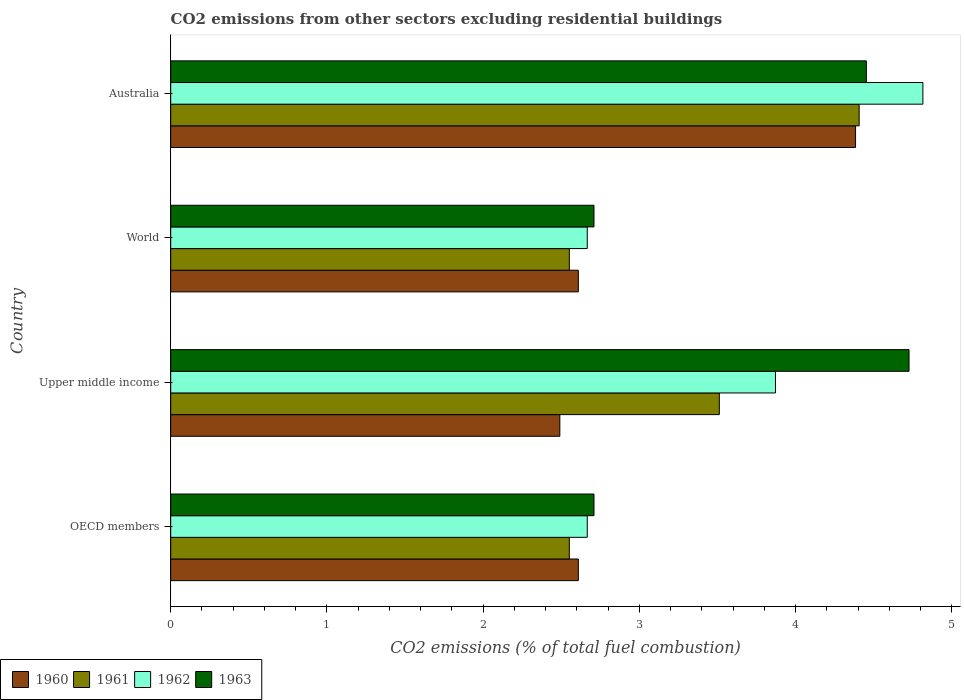How many bars are there on the 1st tick from the top?
Offer a terse response. 4. How many bars are there on the 4th tick from the bottom?
Provide a short and direct response. 4. What is the label of the 4th group of bars from the top?
Offer a terse response. OECD members. What is the total CO2 emitted in 1960 in World?
Provide a succinct answer. 2.61. Across all countries, what is the maximum total CO2 emitted in 1961?
Provide a short and direct response. 4.41. Across all countries, what is the minimum total CO2 emitted in 1961?
Give a very brief answer. 2.55. In which country was the total CO2 emitted in 1960 maximum?
Give a very brief answer. Australia. In which country was the total CO2 emitted in 1961 minimum?
Make the answer very short. OECD members. What is the total total CO2 emitted in 1963 in the graph?
Keep it short and to the point. 14.6. What is the difference between the total CO2 emitted in 1960 in Australia and that in Upper middle income?
Your response must be concise. 1.89. What is the difference between the total CO2 emitted in 1962 in OECD members and the total CO2 emitted in 1963 in Australia?
Offer a very short reply. -1.79. What is the average total CO2 emitted in 1960 per country?
Offer a terse response. 3.02. What is the difference between the total CO2 emitted in 1962 and total CO2 emitted in 1961 in OECD members?
Provide a short and direct response. 0.11. In how many countries, is the total CO2 emitted in 1963 greater than 1.6 ?
Your answer should be compact. 4. What is the ratio of the total CO2 emitted in 1960 in Australia to that in World?
Keep it short and to the point. 1.68. What is the difference between the highest and the second highest total CO2 emitted in 1962?
Your answer should be compact. 0.94. What is the difference between the highest and the lowest total CO2 emitted in 1963?
Your answer should be very brief. 2.02. In how many countries, is the total CO2 emitted in 1962 greater than the average total CO2 emitted in 1962 taken over all countries?
Your response must be concise. 2. What does the 2nd bar from the bottom in World represents?
Ensure brevity in your answer.  1961. Are all the bars in the graph horizontal?
Your answer should be compact. Yes. What is the difference between two consecutive major ticks on the X-axis?
Provide a short and direct response. 1. Does the graph contain grids?
Give a very brief answer. No. What is the title of the graph?
Offer a very short reply. CO2 emissions from other sectors excluding residential buildings. Does "1991" appear as one of the legend labels in the graph?
Your answer should be very brief. No. What is the label or title of the X-axis?
Keep it short and to the point. CO2 emissions (% of total fuel combustion). What is the CO2 emissions (% of total fuel combustion) in 1960 in OECD members?
Make the answer very short. 2.61. What is the CO2 emissions (% of total fuel combustion) of 1961 in OECD members?
Make the answer very short. 2.55. What is the CO2 emissions (% of total fuel combustion) in 1962 in OECD members?
Your answer should be very brief. 2.67. What is the CO2 emissions (% of total fuel combustion) in 1963 in OECD members?
Make the answer very short. 2.71. What is the CO2 emissions (% of total fuel combustion) in 1960 in Upper middle income?
Offer a terse response. 2.49. What is the CO2 emissions (% of total fuel combustion) in 1961 in Upper middle income?
Provide a succinct answer. 3.51. What is the CO2 emissions (% of total fuel combustion) in 1962 in Upper middle income?
Your response must be concise. 3.87. What is the CO2 emissions (% of total fuel combustion) of 1963 in Upper middle income?
Ensure brevity in your answer.  4.73. What is the CO2 emissions (% of total fuel combustion) of 1960 in World?
Your response must be concise. 2.61. What is the CO2 emissions (% of total fuel combustion) in 1961 in World?
Your answer should be very brief. 2.55. What is the CO2 emissions (% of total fuel combustion) in 1962 in World?
Keep it short and to the point. 2.67. What is the CO2 emissions (% of total fuel combustion) in 1963 in World?
Provide a short and direct response. 2.71. What is the CO2 emissions (% of total fuel combustion) of 1960 in Australia?
Provide a succinct answer. 4.38. What is the CO2 emissions (% of total fuel combustion) in 1961 in Australia?
Offer a terse response. 4.41. What is the CO2 emissions (% of total fuel combustion) in 1962 in Australia?
Your response must be concise. 4.82. What is the CO2 emissions (% of total fuel combustion) of 1963 in Australia?
Offer a terse response. 4.45. Across all countries, what is the maximum CO2 emissions (% of total fuel combustion) in 1960?
Ensure brevity in your answer.  4.38. Across all countries, what is the maximum CO2 emissions (% of total fuel combustion) in 1961?
Offer a very short reply. 4.41. Across all countries, what is the maximum CO2 emissions (% of total fuel combustion) of 1962?
Give a very brief answer. 4.82. Across all countries, what is the maximum CO2 emissions (% of total fuel combustion) of 1963?
Provide a succinct answer. 4.73. Across all countries, what is the minimum CO2 emissions (% of total fuel combustion) in 1960?
Your answer should be very brief. 2.49. Across all countries, what is the minimum CO2 emissions (% of total fuel combustion) of 1961?
Offer a terse response. 2.55. Across all countries, what is the minimum CO2 emissions (% of total fuel combustion) in 1962?
Offer a terse response. 2.67. Across all countries, what is the minimum CO2 emissions (% of total fuel combustion) of 1963?
Your answer should be very brief. 2.71. What is the total CO2 emissions (% of total fuel combustion) in 1960 in the graph?
Keep it short and to the point. 12.09. What is the total CO2 emissions (% of total fuel combustion) of 1961 in the graph?
Provide a succinct answer. 13.02. What is the total CO2 emissions (% of total fuel combustion) of 1962 in the graph?
Keep it short and to the point. 14.02. What is the total CO2 emissions (% of total fuel combustion) in 1963 in the graph?
Your answer should be compact. 14.6. What is the difference between the CO2 emissions (% of total fuel combustion) of 1960 in OECD members and that in Upper middle income?
Your answer should be compact. 0.12. What is the difference between the CO2 emissions (% of total fuel combustion) of 1961 in OECD members and that in Upper middle income?
Offer a terse response. -0.96. What is the difference between the CO2 emissions (% of total fuel combustion) in 1962 in OECD members and that in Upper middle income?
Ensure brevity in your answer.  -1.2. What is the difference between the CO2 emissions (% of total fuel combustion) in 1963 in OECD members and that in Upper middle income?
Offer a very short reply. -2.02. What is the difference between the CO2 emissions (% of total fuel combustion) of 1960 in OECD members and that in World?
Provide a short and direct response. 0. What is the difference between the CO2 emissions (% of total fuel combustion) of 1962 in OECD members and that in World?
Offer a terse response. 0. What is the difference between the CO2 emissions (% of total fuel combustion) in 1960 in OECD members and that in Australia?
Keep it short and to the point. -1.77. What is the difference between the CO2 emissions (% of total fuel combustion) in 1961 in OECD members and that in Australia?
Offer a very short reply. -1.86. What is the difference between the CO2 emissions (% of total fuel combustion) in 1962 in OECD members and that in Australia?
Offer a terse response. -2.15. What is the difference between the CO2 emissions (% of total fuel combustion) in 1963 in OECD members and that in Australia?
Provide a short and direct response. -1.74. What is the difference between the CO2 emissions (% of total fuel combustion) in 1960 in Upper middle income and that in World?
Keep it short and to the point. -0.12. What is the difference between the CO2 emissions (% of total fuel combustion) of 1961 in Upper middle income and that in World?
Give a very brief answer. 0.96. What is the difference between the CO2 emissions (% of total fuel combustion) of 1962 in Upper middle income and that in World?
Offer a very short reply. 1.2. What is the difference between the CO2 emissions (% of total fuel combustion) of 1963 in Upper middle income and that in World?
Your answer should be compact. 2.02. What is the difference between the CO2 emissions (% of total fuel combustion) of 1960 in Upper middle income and that in Australia?
Provide a short and direct response. -1.89. What is the difference between the CO2 emissions (% of total fuel combustion) in 1961 in Upper middle income and that in Australia?
Give a very brief answer. -0.9. What is the difference between the CO2 emissions (% of total fuel combustion) in 1962 in Upper middle income and that in Australia?
Your response must be concise. -0.94. What is the difference between the CO2 emissions (% of total fuel combustion) of 1963 in Upper middle income and that in Australia?
Ensure brevity in your answer.  0.27. What is the difference between the CO2 emissions (% of total fuel combustion) in 1960 in World and that in Australia?
Ensure brevity in your answer.  -1.77. What is the difference between the CO2 emissions (% of total fuel combustion) of 1961 in World and that in Australia?
Give a very brief answer. -1.86. What is the difference between the CO2 emissions (% of total fuel combustion) in 1962 in World and that in Australia?
Provide a short and direct response. -2.15. What is the difference between the CO2 emissions (% of total fuel combustion) of 1963 in World and that in Australia?
Offer a very short reply. -1.74. What is the difference between the CO2 emissions (% of total fuel combustion) in 1960 in OECD members and the CO2 emissions (% of total fuel combustion) in 1961 in Upper middle income?
Provide a succinct answer. -0.9. What is the difference between the CO2 emissions (% of total fuel combustion) of 1960 in OECD members and the CO2 emissions (% of total fuel combustion) of 1962 in Upper middle income?
Offer a terse response. -1.26. What is the difference between the CO2 emissions (% of total fuel combustion) in 1960 in OECD members and the CO2 emissions (% of total fuel combustion) in 1963 in Upper middle income?
Give a very brief answer. -2.12. What is the difference between the CO2 emissions (% of total fuel combustion) of 1961 in OECD members and the CO2 emissions (% of total fuel combustion) of 1962 in Upper middle income?
Make the answer very short. -1.32. What is the difference between the CO2 emissions (% of total fuel combustion) of 1961 in OECD members and the CO2 emissions (% of total fuel combustion) of 1963 in Upper middle income?
Give a very brief answer. -2.17. What is the difference between the CO2 emissions (% of total fuel combustion) of 1962 in OECD members and the CO2 emissions (% of total fuel combustion) of 1963 in Upper middle income?
Offer a terse response. -2.06. What is the difference between the CO2 emissions (% of total fuel combustion) of 1960 in OECD members and the CO2 emissions (% of total fuel combustion) of 1961 in World?
Ensure brevity in your answer.  0.06. What is the difference between the CO2 emissions (% of total fuel combustion) of 1960 in OECD members and the CO2 emissions (% of total fuel combustion) of 1962 in World?
Keep it short and to the point. -0.06. What is the difference between the CO2 emissions (% of total fuel combustion) in 1960 in OECD members and the CO2 emissions (% of total fuel combustion) in 1963 in World?
Offer a very short reply. -0.1. What is the difference between the CO2 emissions (% of total fuel combustion) in 1961 in OECD members and the CO2 emissions (% of total fuel combustion) in 1962 in World?
Give a very brief answer. -0.12. What is the difference between the CO2 emissions (% of total fuel combustion) in 1961 in OECD members and the CO2 emissions (% of total fuel combustion) in 1963 in World?
Make the answer very short. -0.16. What is the difference between the CO2 emissions (% of total fuel combustion) in 1962 in OECD members and the CO2 emissions (% of total fuel combustion) in 1963 in World?
Provide a short and direct response. -0.04. What is the difference between the CO2 emissions (% of total fuel combustion) in 1960 in OECD members and the CO2 emissions (% of total fuel combustion) in 1961 in Australia?
Offer a very short reply. -1.8. What is the difference between the CO2 emissions (% of total fuel combustion) of 1960 in OECD members and the CO2 emissions (% of total fuel combustion) of 1962 in Australia?
Make the answer very short. -2.21. What is the difference between the CO2 emissions (% of total fuel combustion) in 1960 in OECD members and the CO2 emissions (% of total fuel combustion) in 1963 in Australia?
Offer a very short reply. -1.84. What is the difference between the CO2 emissions (% of total fuel combustion) of 1961 in OECD members and the CO2 emissions (% of total fuel combustion) of 1962 in Australia?
Offer a terse response. -2.26. What is the difference between the CO2 emissions (% of total fuel combustion) in 1961 in OECD members and the CO2 emissions (% of total fuel combustion) in 1963 in Australia?
Offer a terse response. -1.9. What is the difference between the CO2 emissions (% of total fuel combustion) of 1962 in OECD members and the CO2 emissions (% of total fuel combustion) of 1963 in Australia?
Your response must be concise. -1.79. What is the difference between the CO2 emissions (% of total fuel combustion) in 1960 in Upper middle income and the CO2 emissions (% of total fuel combustion) in 1961 in World?
Your response must be concise. -0.06. What is the difference between the CO2 emissions (% of total fuel combustion) of 1960 in Upper middle income and the CO2 emissions (% of total fuel combustion) of 1962 in World?
Keep it short and to the point. -0.18. What is the difference between the CO2 emissions (% of total fuel combustion) of 1960 in Upper middle income and the CO2 emissions (% of total fuel combustion) of 1963 in World?
Offer a very short reply. -0.22. What is the difference between the CO2 emissions (% of total fuel combustion) of 1961 in Upper middle income and the CO2 emissions (% of total fuel combustion) of 1962 in World?
Make the answer very short. 0.85. What is the difference between the CO2 emissions (% of total fuel combustion) of 1961 in Upper middle income and the CO2 emissions (% of total fuel combustion) of 1963 in World?
Your answer should be very brief. 0.8. What is the difference between the CO2 emissions (% of total fuel combustion) in 1962 in Upper middle income and the CO2 emissions (% of total fuel combustion) in 1963 in World?
Make the answer very short. 1.16. What is the difference between the CO2 emissions (% of total fuel combustion) of 1960 in Upper middle income and the CO2 emissions (% of total fuel combustion) of 1961 in Australia?
Provide a succinct answer. -1.92. What is the difference between the CO2 emissions (% of total fuel combustion) in 1960 in Upper middle income and the CO2 emissions (% of total fuel combustion) in 1962 in Australia?
Make the answer very short. -2.32. What is the difference between the CO2 emissions (% of total fuel combustion) in 1960 in Upper middle income and the CO2 emissions (% of total fuel combustion) in 1963 in Australia?
Offer a terse response. -1.96. What is the difference between the CO2 emissions (% of total fuel combustion) in 1961 in Upper middle income and the CO2 emissions (% of total fuel combustion) in 1962 in Australia?
Ensure brevity in your answer.  -1.3. What is the difference between the CO2 emissions (% of total fuel combustion) of 1961 in Upper middle income and the CO2 emissions (% of total fuel combustion) of 1963 in Australia?
Provide a succinct answer. -0.94. What is the difference between the CO2 emissions (% of total fuel combustion) in 1962 in Upper middle income and the CO2 emissions (% of total fuel combustion) in 1963 in Australia?
Provide a short and direct response. -0.58. What is the difference between the CO2 emissions (% of total fuel combustion) in 1960 in World and the CO2 emissions (% of total fuel combustion) in 1961 in Australia?
Offer a very short reply. -1.8. What is the difference between the CO2 emissions (% of total fuel combustion) of 1960 in World and the CO2 emissions (% of total fuel combustion) of 1962 in Australia?
Make the answer very short. -2.21. What is the difference between the CO2 emissions (% of total fuel combustion) in 1960 in World and the CO2 emissions (% of total fuel combustion) in 1963 in Australia?
Offer a terse response. -1.84. What is the difference between the CO2 emissions (% of total fuel combustion) in 1961 in World and the CO2 emissions (% of total fuel combustion) in 1962 in Australia?
Your response must be concise. -2.26. What is the difference between the CO2 emissions (% of total fuel combustion) in 1961 in World and the CO2 emissions (% of total fuel combustion) in 1963 in Australia?
Your answer should be compact. -1.9. What is the difference between the CO2 emissions (% of total fuel combustion) of 1962 in World and the CO2 emissions (% of total fuel combustion) of 1963 in Australia?
Ensure brevity in your answer.  -1.79. What is the average CO2 emissions (% of total fuel combustion) of 1960 per country?
Make the answer very short. 3.02. What is the average CO2 emissions (% of total fuel combustion) in 1961 per country?
Make the answer very short. 3.26. What is the average CO2 emissions (% of total fuel combustion) of 1962 per country?
Ensure brevity in your answer.  3.5. What is the average CO2 emissions (% of total fuel combustion) in 1963 per country?
Give a very brief answer. 3.65. What is the difference between the CO2 emissions (% of total fuel combustion) in 1960 and CO2 emissions (% of total fuel combustion) in 1961 in OECD members?
Make the answer very short. 0.06. What is the difference between the CO2 emissions (% of total fuel combustion) in 1960 and CO2 emissions (% of total fuel combustion) in 1962 in OECD members?
Provide a succinct answer. -0.06. What is the difference between the CO2 emissions (% of total fuel combustion) of 1960 and CO2 emissions (% of total fuel combustion) of 1963 in OECD members?
Offer a very short reply. -0.1. What is the difference between the CO2 emissions (% of total fuel combustion) in 1961 and CO2 emissions (% of total fuel combustion) in 1962 in OECD members?
Make the answer very short. -0.12. What is the difference between the CO2 emissions (% of total fuel combustion) in 1961 and CO2 emissions (% of total fuel combustion) in 1963 in OECD members?
Make the answer very short. -0.16. What is the difference between the CO2 emissions (% of total fuel combustion) of 1962 and CO2 emissions (% of total fuel combustion) of 1963 in OECD members?
Offer a terse response. -0.04. What is the difference between the CO2 emissions (% of total fuel combustion) of 1960 and CO2 emissions (% of total fuel combustion) of 1961 in Upper middle income?
Offer a very short reply. -1.02. What is the difference between the CO2 emissions (% of total fuel combustion) in 1960 and CO2 emissions (% of total fuel combustion) in 1962 in Upper middle income?
Your response must be concise. -1.38. What is the difference between the CO2 emissions (% of total fuel combustion) of 1960 and CO2 emissions (% of total fuel combustion) of 1963 in Upper middle income?
Ensure brevity in your answer.  -2.24. What is the difference between the CO2 emissions (% of total fuel combustion) in 1961 and CO2 emissions (% of total fuel combustion) in 1962 in Upper middle income?
Make the answer very short. -0.36. What is the difference between the CO2 emissions (% of total fuel combustion) in 1961 and CO2 emissions (% of total fuel combustion) in 1963 in Upper middle income?
Offer a very short reply. -1.21. What is the difference between the CO2 emissions (% of total fuel combustion) in 1962 and CO2 emissions (% of total fuel combustion) in 1963 in Upper middle income?
Keep it short and to the point. -0.85. What is the difference between the CO2 emissions (% of total fuel combustion) of 1960 and CO2 emissions (% of total fuel combustion) of 1961 in World?
Offer a very short reply. 0.06. What is the difference between the CO2 emissions (% of total fuel combustion) in 1960 and CO2 emissions (% of total fuel combustion) in 1962 in World?
Offer a very short reply. -0.06. What is the difference between the CO2 emissions (% of total fuel combustion) in 1960 and CO2 emissions (% of total fuel combustion) in 1963 in World?
Your answer should be compact. -0.1. What is the difference between the CO2 emissions (% of total fuel combustion) in 1961 and CO2 emissions (% of total fuel combustion) in 1962 in World?
Offer a very short reply. -0.12. What is the difference between the CO2 emissions (% of total fuel combustion) of 1961 and CO2 emissions (% of total fuel combustion) of 1963 in World?
Offer a terse response. -0.16. What is the difference between the CO2 emissions (% of total fuel combustion) in 1962 and CO2 emissions (% of total fuel combustion) in 1963 in World?
Keep it short and to the point. -0.04. What is the difference between the CO2 emissions (% of total fuel combustion) of 1960 and CO2 emissions (% of total fuel combustion) of 1961 in Australia?
Your answer should be compact. -0.02. What is the difference between the CO2 emissions (% of total fuel combustion) in 1960 and CO2 emissions (% of total fuel combustion) in 1962 in Australia?
Make the answer very short. -0.43. What is the difference between the CO2 emissions (% of total fuel combustion) of 1960 and CO2 emissions (% of total fuel combustion) of 1963 in Australia?
Give a very brief answer. -0.07. What is the difference between the CO2 emissions (% of total fuel combustion) in 1961 and CO2 emissions (% of total fuel combustion) in 1962 in Australia?
Keep it short and to the point. -0.41. What is the difference between the CO2 emissions (% of total fuel combustion) of 1961 and CO2 emissions (% of total fuel combustion) of 1963 in Australia?
Provide a succinct answer. -0.05. What is the difference between the CO2 emissions (% of total fuel combustion) in 1962 and CO2 emissions (% of total fuel combustion) in 1963 in Australia?
Your response must be concise. 0.36. What is the ratio of the CO2 emissions (% of total fuel combustion) in 1960 in OECD members to that in Upper middle income?
Your answer should be very brief. 1.05. What is the ratio of the CO2 emissions (% of total fuel combustion) in 1961 in OECD members to that in Upper middle income?
Keep it short and to the point. 0.73. What is the ratio of the CO2 emissions (% of total fuel combustion) of 1962 in OECD members to that in Upper middle income?
Your response must be concise. 0.69. What is the ratio of the CO2 emissions (% of total fuel combustion) in 1963 in OECD members to that in Upper middle income?
Provide a succinct answer. 0.57. What is the ratio of the CO2 emissions (% of total fuel combustion) of 1961 in OECD members to that in World?
Your answer should be very brief. 1. What is the ratio of the CO2 emissions (% of total fuel combustion) in 1962 in OECD members to that in World?
Provide a succinct answer. 1. What is the ratio of the CO2 emissions (% of total fuel combustion) in 1963 in OECD members to that in World?
Your response must be concise. 1. What is the ratio of the CO2 emissions (% of total fuel combustion) in 1960 in OECD members to that in Australia?
Your answer should be very brief. 0.6. What is the ratio of the CO2 emissions (% of total fuel combustion) in 1961 in OECD members to that in Australia?
Offer a terse response. 0.58. What is the ratio of the CO2 emissions (% of total fuel combustion) of 1962 in OECD members to that in Australia?
Provide a succinct answer. 0.55. What is the ratio of the CO2 emissions (% of total fuel combustion) in 1963 in OECD members to that in Australia?
Provide a short and direct response. 0.61. What is the ratio of the CO2 emissions (% of total fuel combustion) in 1960 in Upper middle income to that in World?
Offer a terse response. 0.95. What is the ratio of the CO2 emissions (% of total fuel combustion) in 1961 in Upper middle income to that in World?
Make the answer very short. 1.38. What is the ratio of the CO2 emissions (% of total fuel combustion) of 1962 in Upper middle income to that in World?
Provide a succinct answer. 1.45. What is the ratio of the CO2 emissions (% of total fuel combustion) of 1963 in Upper middle income to that in World?
Make the answer very short. 1.74. What is the ratio of the CO2 emissions (% of total fuel combustion) of 1960 in Upper middle income to that in Australia?
Ensure brevity in your answer.  0.57. What is the ratio of the CO2 emissions (% of total fuel combustion) of 1961 in Upper middle income to that in Australia?
Your answer should be compact. 0.8. What is the ratio of the CO2 emissions (% of total fuel combustion) of 1962 in Upper middle income to that in Australia?
Keep it short and to the point. 0.8. What is the ratio of the CO2 emissions (% of total fuel combustion) in 1963 in Upper middle income to that in Australia?
Provide a short and direct response. 1.06. What is the ratio of the CO2 emissions (% of total fuel combustion) of 1960 in World to that in Australia?
Keep it short and to the point. 0.6. What is the ratio of the CO2 emissions (% of total fuel combustion) of 1961 in World to that in Australia?
Make the answer very short. 0.58. What is the ratio of the CO2 emissions (% of total fuel combustion) in 1962 in World to that in Australia?
Provide a short and direct response. 0.55. What is the ratio of the CO2 emissions (% of total fuel combustion) in 1963 in World to that in Australia?
Provide a short and direct response. 0.61. What is the difference between the highest and the second highest CO2 emissions (% of total fuel combustion) in 1960?
Keep it short and to the point. 1.77. What is the difference between the highest and the second highest CO2 emissions (% of total fuel combustion) of 1961?
Your answer should be compact. 0.9. What is the difference between the highest and the second highest CO2 emissions (% of total fuel combustion) of 1962?
Ensure brevity in your answer.  0.94. What is the difference between the highest and the second highest CO2 emissions (% of total fuel combustion) in 1963?
Your response must be concise. 0.27. What is the difference between the highest and the lowest CO2 emissions (% of total fuel combustion) in 1960?
Provide a succinct answer. 1.89. What is the difference between the highest and the lowest CO2 emissions (% of total fuel combustion) of 1961?
Give a very brief answer. 1.86. What is the difference between the highest and the lowest CO2 emissions (% of total fuel combustion) in 1962?
Offer a terse response. 2.15. What is the difference between the highest and the lowest CO2 emissions (% of total fuel combustion) of 1963?
Give a very brief answer. 2.02. 